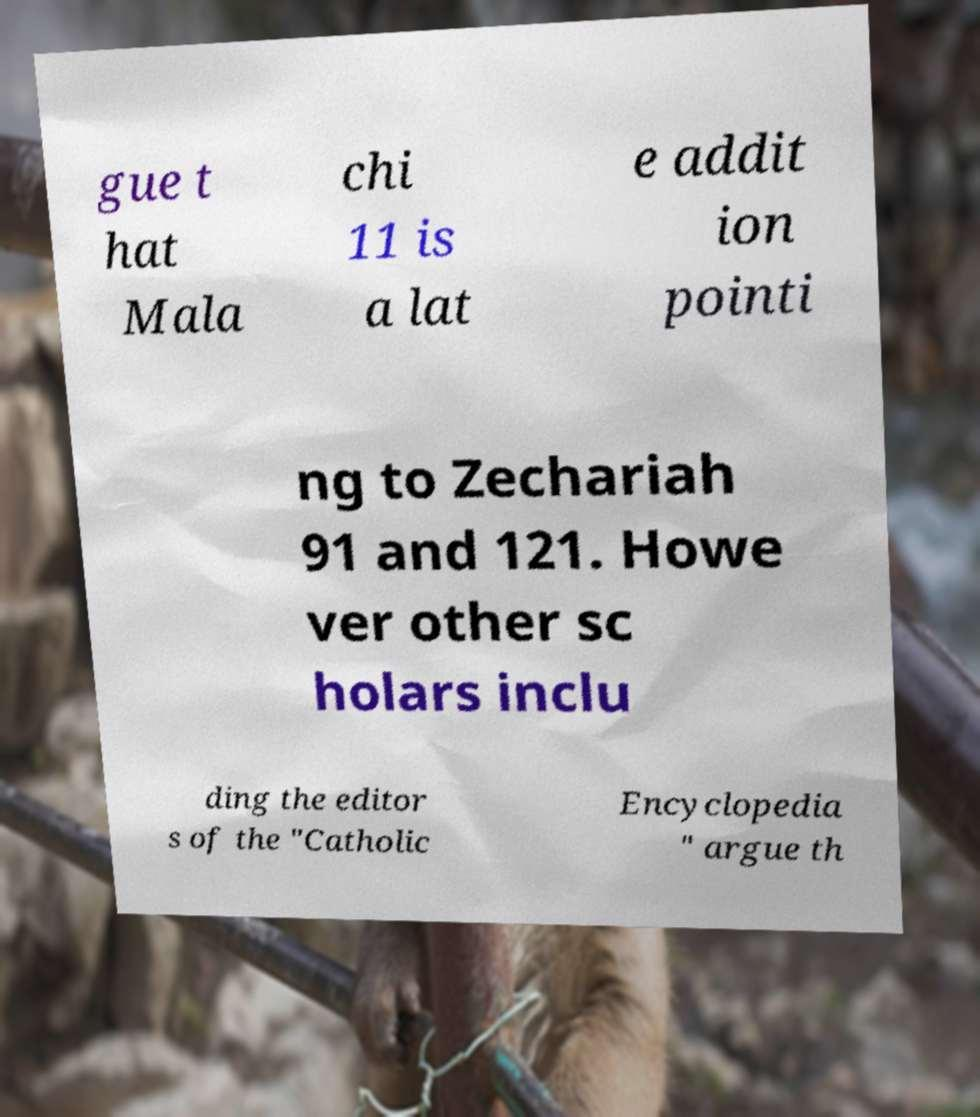Can you accurately transcribe the text from the provided image for me? gue t hat Mala chi 11 is a lat e addit ion pointi ng to Zechariah 91 and 121. Howe ver other sc holars inclu ding the editor s of the "Catholic Encyclopedia " argue th 